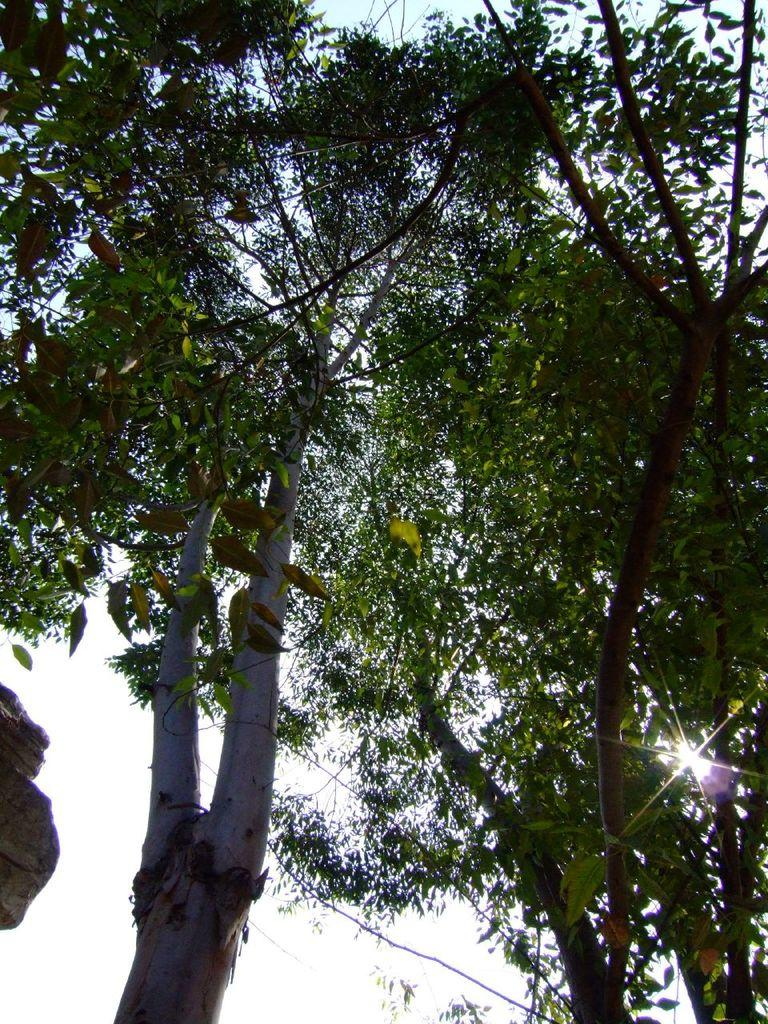What type of vegetation can be seen in the image? There are trees in the image. What part of the natural environment is visible in the image? The sky is visible in the image. Can the sun be seen in the image? Yes, the sun is shining in the sky. What type of queen is depicted in the image? There is no queen present in the image; it features trees and the sky. What type of mine is visible in the image? There is no mine present in the image; it features trees and the sky. 